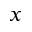<formula> <loc_0><loc_0><loc_500><loc_500>x</formula> 